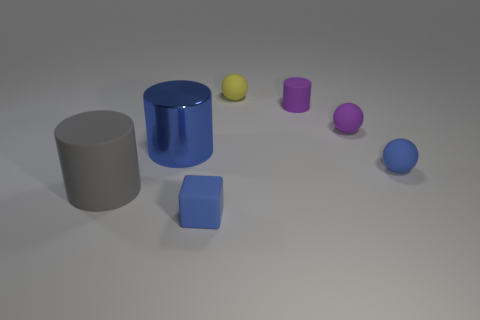What number of blue objects are either big metallic cylinders or small things?
Give a very brief answer. 3. The small sphere behind the small purple matte object to the right of the purple rubber cylinder is what color?
Provide a succinct answer. Yellow. There is a large cylinder that is the same color as the small rubber block; what is its material?
Provide a short and direct response. Metal. What is the color of the sphere that is to the left of the tiny purple matte cylinder?
Make the answer very short. Yellow. There is a rubber thing that is on the left side of the blue block; is it the same size as the yellow rubber object?
Offer a terse response. No. The rubber sphere that is the same color as the large shiny cylinder is what size?
Your response must be concise. Small. Are there any blue metallic things of the same size as the purple matte cylinder?
Make the answer very short. No. There is a matte sphere that is in front of the blue shiny thing; is it the same color as the tiny rubber object that is in front of the large rubber cylinder?
Make the answer very short. Yes. Is there a rubber thing that has the same color as the metallic cylinder?
Keep it short and to the point. Yes. What number of other objects are there of the same shape as the big gray matte thing?
Your response must be concise. 2. 